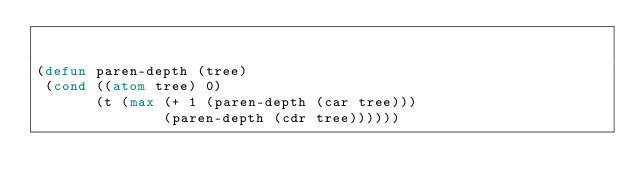<code> <loc_0><loc_0><loc_500><loc_500><_Lisp_>

(defun paren-depth (tree)
 (cond ((atom tree) 0)
       (t (max (+ 1 (paren-depth (car tree)))
               (paren-depth (cdr tree))))))
</code> 